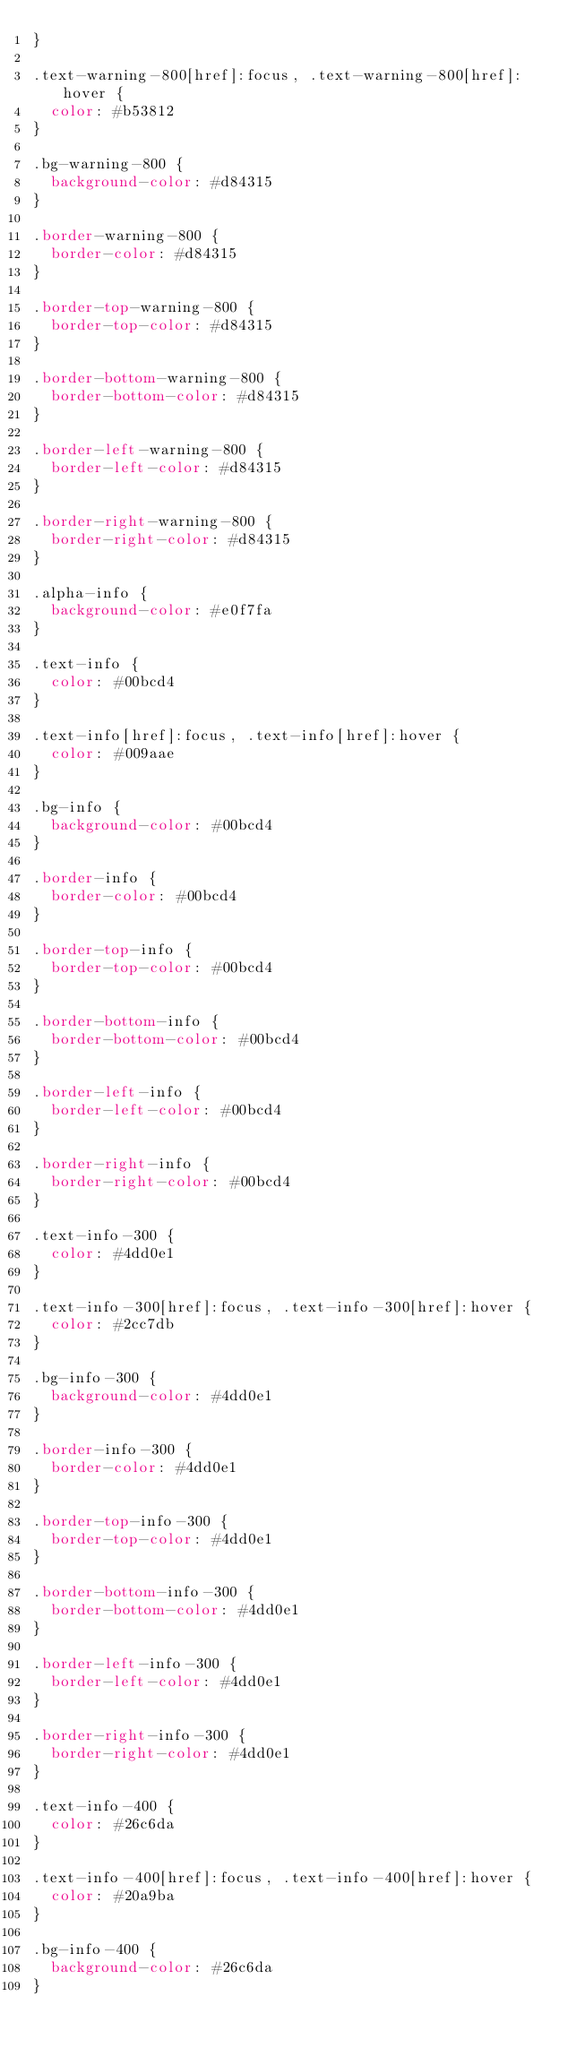Convert code to text. <code><loc_0><loc_0><loc_500><loc_500><_CSS_>}

.text-warning-800[href]:focus, .text-warning-800[href]:hover {
  color: #b53812
}

.bg-warning-800 {
  background-color: #d84315
}

.border-warning-800 {
  border-color: #d84315
}

.border-top-warning-800 {
  border-top-color: #d84315
}

.border-bottom-warning-800 {
  border-bottom-color: #d84315
}

.border-left-warning-800 {
  border-left-color: #d84315
}

.border-right-warning-800 {
  border-right-color: #d84315
}

.alpha-info {
  background-color: #e0f7fa
}

.text-info {
  color: #00bcd4
}

.text-info[href]:focus, .text-info[href]:hover {
  color: #009aae
}

.bg-info {
  background-color: #00bcd4
}

.border-info {
  border-color: #00bcd4
}

.border-top-info {
  border-top-color: #00bcd4
}

.border-bottom-info {
  border-bottom-color: #00bcd4
}

.border-left-info {
  border-left-color: #00bcd4
}

.border-right-info {
  border-right-color: #00bcd4
}

.text-info-300 {
  color: #4dd0e1
}

.text-info-300[href]:focus, .text-info-300[href]:hover {
  color: #2cc7db
}

.bg-info-300 {
  background-color: #4dd0e1
}

.border-info-300 {
  border-color: #4dd0e1
}

.border-top-info-300 {
  border-top-color: #4dd0e1
}

.border-bottom-info-300 {
  border-bottom-color: #4dd0e1
}

.border-left-info-300 {
  border-left-color: #4dd0e1
}

.border-right-info-300 {
  border-right-color: #4dd0e1
}

.text-info-400 {
  color: #26c6da
}

.text-info-400[href]:focus, .text-info-400[href]:hover {
  color: #20a9ba
}

.bg-info-400 {
  background-color: #26c6da
}
</code> 